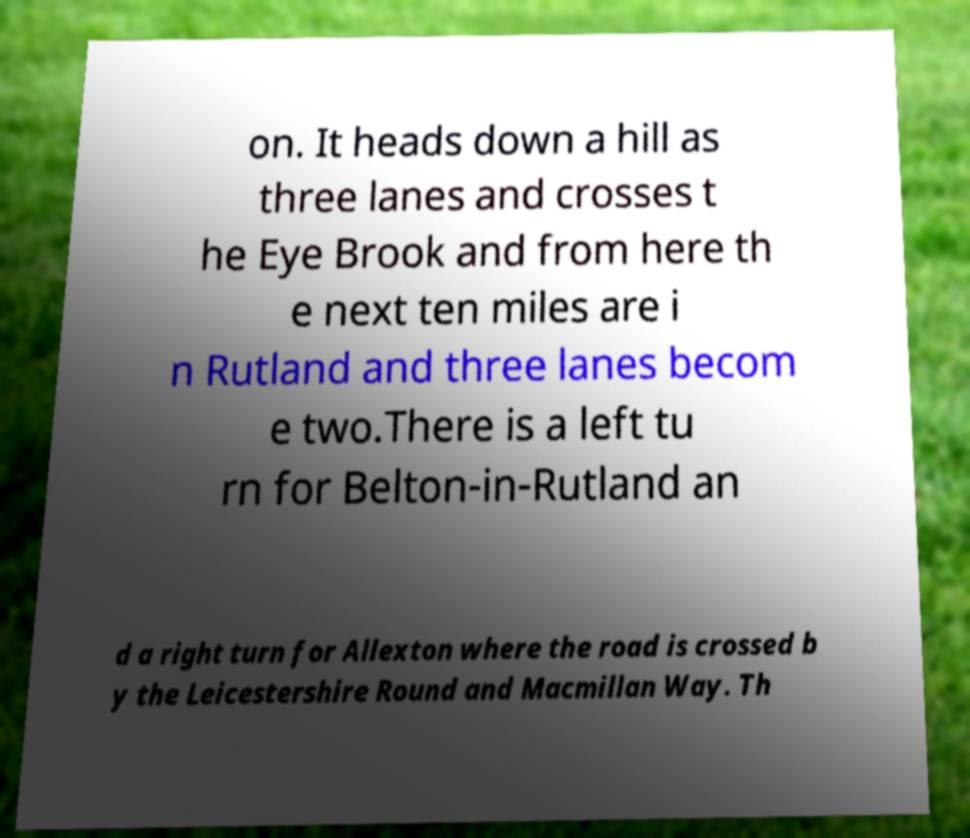Can you accurately transcribe the text from the provided image for me? on. It heads down a hill as three lanes and crosses t he Eye Brook and from here th e next ten miles are i n Rutland and three lanes becom e two.There is a left tu rn for Belton-in-Rutland an d a right turn for Allexton where the road is crossed b y the Leicestershire Round and Macmillan Way. Th 